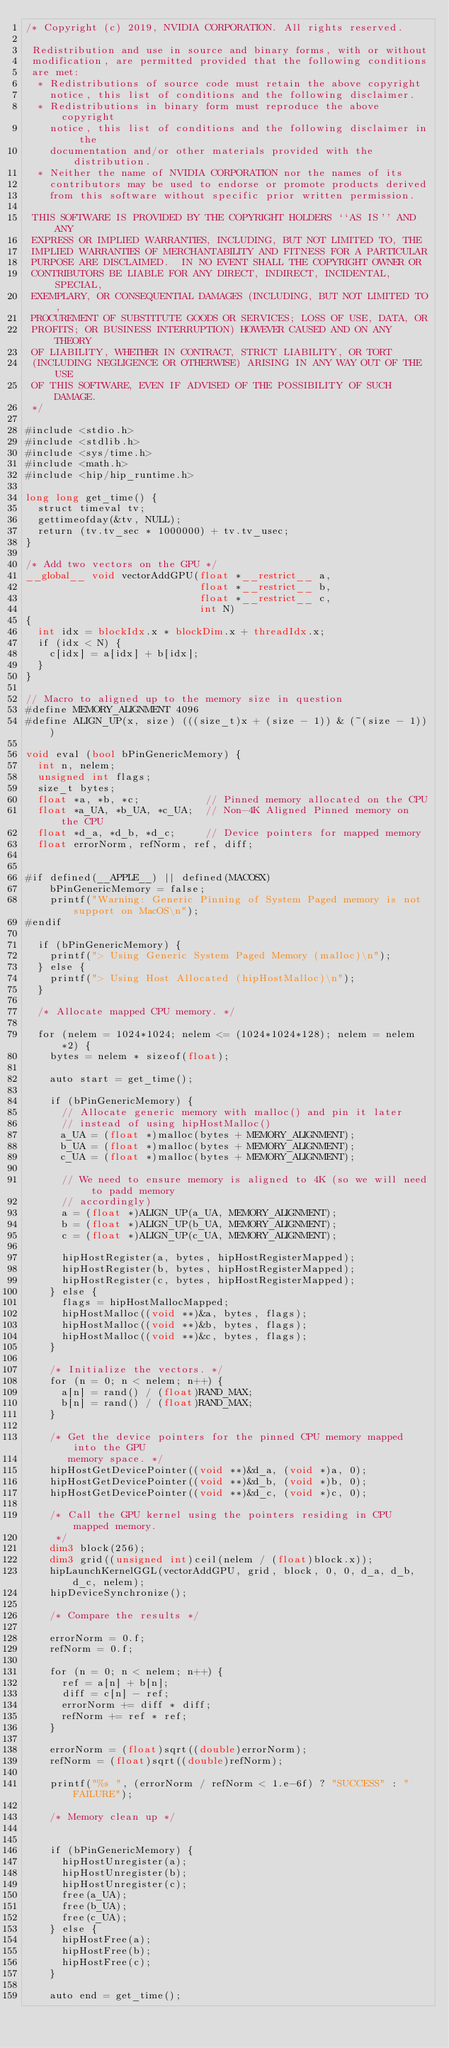<code> <loc_0><loc_0><loc_500><loc_500><_Cuda_>/* Copyright (c) 2019, NVIDIA CORPORATION. All rights reserved.

 Redistribution and use in source and binary forms, with or without
 modification, are permitted provided that the following conditions
 are met:
  * Redistributions of source code must retain the above copyright
    notice, this list of conditions and the following disclaimer.
  * Redistributions in binary form must reproduce the above copyright
    notice, this list of conditions and the following disclaimer in the
    documentation and/or other materials provided with the distribution.
  * Neither the name of NVIDIA CORPORATION nor the names of its
    contributors may be used to endorse or promote products derived
    from this software without specific prior written permission.

 THIS SOFTWARE IS PROVIDED BY THE COPYRIGHT HOLDERS ``AS IS'' AND ANY
 EXPRESS OR IMPLIED WARRANTIES, INCLUDING, BUT NOT LIMITED TO, THE
 IMPLIED WARRANTIES OF MERCHANTABILITY AND FITNESS FOR A PARTICULAR
 PURPOSE ARE DISCLAIMED.  IN NO EVENT SHALL THE COPYRIGHT OWNER OR
 CONTRIBUTORS BE LIABLE FOR ANY DIRECT, INDIRECT, INCIDENTAL, SPECIAL,
 EXEMPLARY, OR CONSEQUENTIAL DAMAGES (INCLUDING, BUT NOT LIMITED TO,
 PROCUREMENT OF SUBSTITUTE GOODS OR SERVICES; LOSS OF USE, DATA, OR
 PROFITS; OR BUSINESS INTERRUPTION) HOWEVER CAUSED AND ON ANY THEORY
 OF LIABILITY, WHETHER IN CONTRACT, STRICT LIABILITY, OR TORT
 (INCLUDING NEGLIGENCE OR OTHERWISE) ARISING IN ANY WAY OUT OF THE USE
 OF THIS SOFTWARE, EVEN IF ADVISED OF THE POSSIBILITY OF SUCH DAMAGE.
 */

#include <stdio.h>
#include <stdlib.h>
#include <sys/time.h>
#include <math.h>
#include <hip/hip_runtime.h>

long long get_time() {
  struct timeval tv;
  gettimeofday(&tv, NULL);
  return (tv.tv_sec * 1000000) + tv.tv_usec;
}

/* Add two vectors on the GPU */
__global__ void vectorAddGPU(float *__restrict__ a,
                             float *__restrict__ b,
                             float *__restrict__ c,
                             int N) 
{
  int idx = blockIdx.x * blockDim.x + threadIdx.x;
  if (idx < N) {
    c[idx] = a[idx] + b[idx];
  }
}

// Macro to aligned up to the memory size in question
#define MEMORY_ALIGNMENT 4096
#define ALIGN_UP(x, size) (((size_t)x + (size - 1)) & (~(size - 1)))

void eval (bool bPinGenericMemory) {
  int n, nelem;
  unsigned int flags;
  size_t bytes;
  float *a, *b, *c;           // Pinned memory allocated on the CPU
  float *a_UA, *b_UA, *c_UA;  // Non-4K Aligned Pinned memory on the CPU
  float *d_a, *d_b, *d_c;     // Device pointers for mapped memory
  float errorNorm, refNorm, ref, diff;


#if defined(__APPLE__) || defined(MACOSX)
    bPinGenericMemory = false;
    printf("Warning: Generic Pinning of System Paged memory is not support on MacOS\n");
#endif

  if (bPinGenericMemory) {
    printf("> Using Generic System Paged Memory (malloc)\n");
  } else {
    printf("> Using Host Allocated (hipHostMalloc)\n");
  }

  /* Allocate mapped CPU memory. */

  for (nelem = 1024*1024; nelem <= (1024*1024*128); nelem = nelem*2) {
    bytes = nelem * sizeof(float);

    auto start = get_time();

    if (bPinGenericMemory) {
      // Allocate generic memory with malloc() and pin it later 
      // instead of using hipHostMalloc()
      a_UA = (float *)malloc(bytes + MEMORY_ALIGNMENT);
      b_UA = (float *)malloc(bytes + MEMORY_ALIGNMENT);
      c_UA = (float *)malloc(bytes + MEMORY_ALIGNMENT);

      // We need to ensure memory is aligned to 4K (so we will need to padd memory
      // accordingly)
      a = (float *)ALIGN_UP(a_UA, MEMORY_ALIGNMENT);
      b = (float *)ALIGN_UP(b_UA, MEMORY_ALIGNMENT);
      c = (float *)ALIGN_UP(c_UA, MEMORY_ALIGNMENT);

      hipHostRegister(a, bytes, hipHostRegisterMapped);
      hipHostRegister(b, bytes, hipHostRegisterMapped);
      hipHostRegister(c, bytes, hipHostRegisterMapped);
    } else {
      flags = hipHostMallocMapped;
      hipHostMalloc((void **)&a, bytes, flags);
      hipHostMalloc((void **)&b, bytes, flags);
      hipHostMalloc((void **)&c, bytes, flags);
    }

    /* Initialize the vectors. */
    for (n = 0; n < nelem; n++) {
      a[n] = rand() / (float)RAND_MAX;
      b[n] = rand() / (float)RAND_MAX;
    }

    /* Get the device pointers for the pinned CPU memory mapped into the GPU
       memory space. */
    hipHostGetDevicePointer((void **)&d_a, (void *)a, 0);
    hipHostGetDevicePointer((void **)&d_b, (void *)b, 0);
    hipHostGetDevicePointer((void **)&d_c, (void *)c, 0);

    /* Call the GPU kernel using the pointers residing in CPU mapped memory.
     */
    dim3 block(256);
    dim3 grid((unsigned int)ceil(nelem / (float)block.x));
    hipLaunchKernelGGL(vectorAddGPU, grid, block, 0, 0, d_a, d_b, d_c, nelem);
    hipDeviceSynchronize();

    /* Compare the results */

    errorNorm = 0.f;
    refNorm = 0.f;

    for (n = 0; n < nelem; n++) {
      ref = a[n] + b[n];
      diff = c[n] - ref;
      errorNorm += diff * diff;
      refNorm += ref * ref;
    }

    errorNorm = (float)sqrt((double)errorNorm);
    refNorm = (float)sqrt((double)refNorm);

    printf("%s ", (errorNorm / refNorm < 1.e-6f) ? "SUCCESS" : "FAILURE");

    /* Memory clean up */


    if (bPinGenericMemory) {
      hipHostUnregister(a);
      hipHostUnregister(b);
      hipHostUnregister(c);
      free(a_UA);
      free(b_UA);
      free(c_UA);
    } else {
      hipHostFree(a);
      hipHostFree(b);
      hipHostFree(c);
    }

    auto end = get_time();</code> 